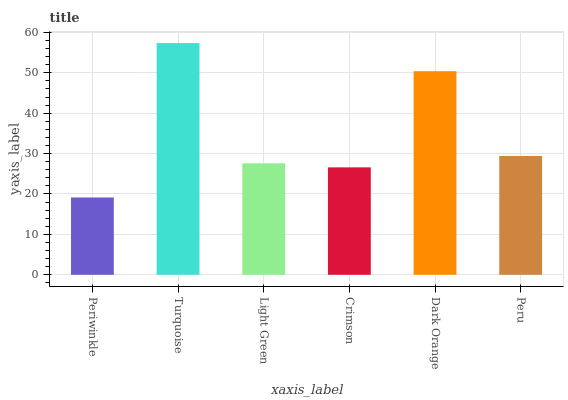Is Periwinkle the minimum?
Answer yes or no. Yes. Is Turquoise the maximum?
Answer yes or no. Yes. Is Light Green the minimum?
Answer yes or no. No. Is Light Green the maximum?
Answer yes or no. No. Is Turquoise greater than Light Green?
Answer yes or no. Yes. Is Light Green less than Turquoise?
Answer yes or no. Yes. Is Light Green greater than Turquoise?
Answer yes or no. No. Is Turquoise less than Light Green?
Answer yes or no. No. Is Peru the high median?
Answer yes or no. Yes. Is Light Green the low median?
Answer yes or no. Yes. Is Light Green the high median?
Answer yes or no. No. Is Dark Orange the low median?
Answer yes or no. No. 